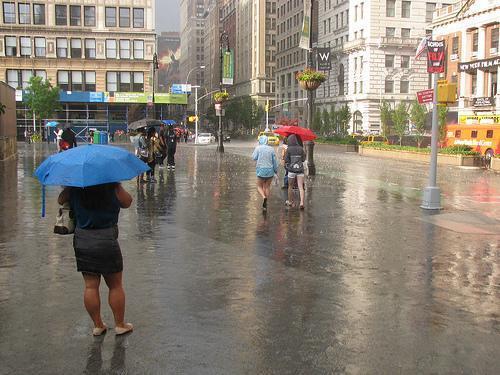How many people are walking under the red umbrella?
Give a very brief answer. 1. 